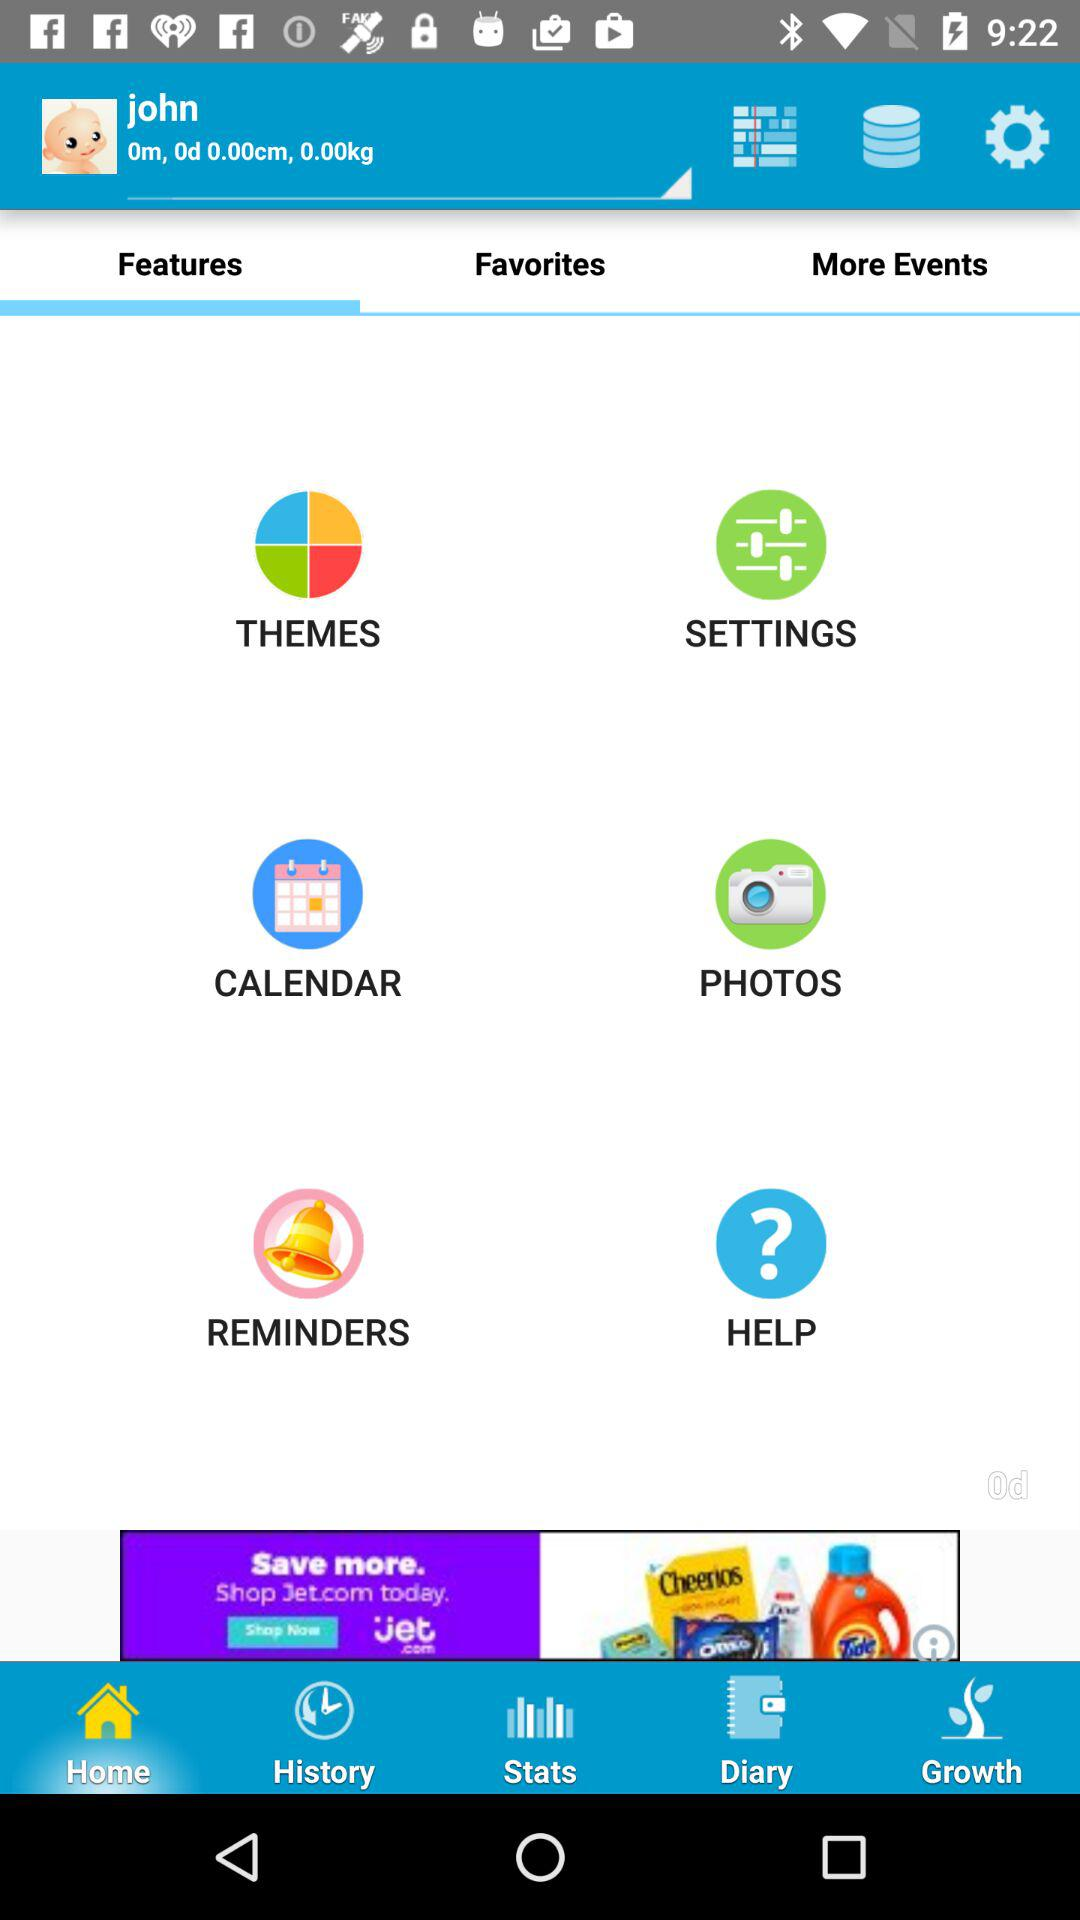How old was the baby? The baby was 0 months and 0 days old. 